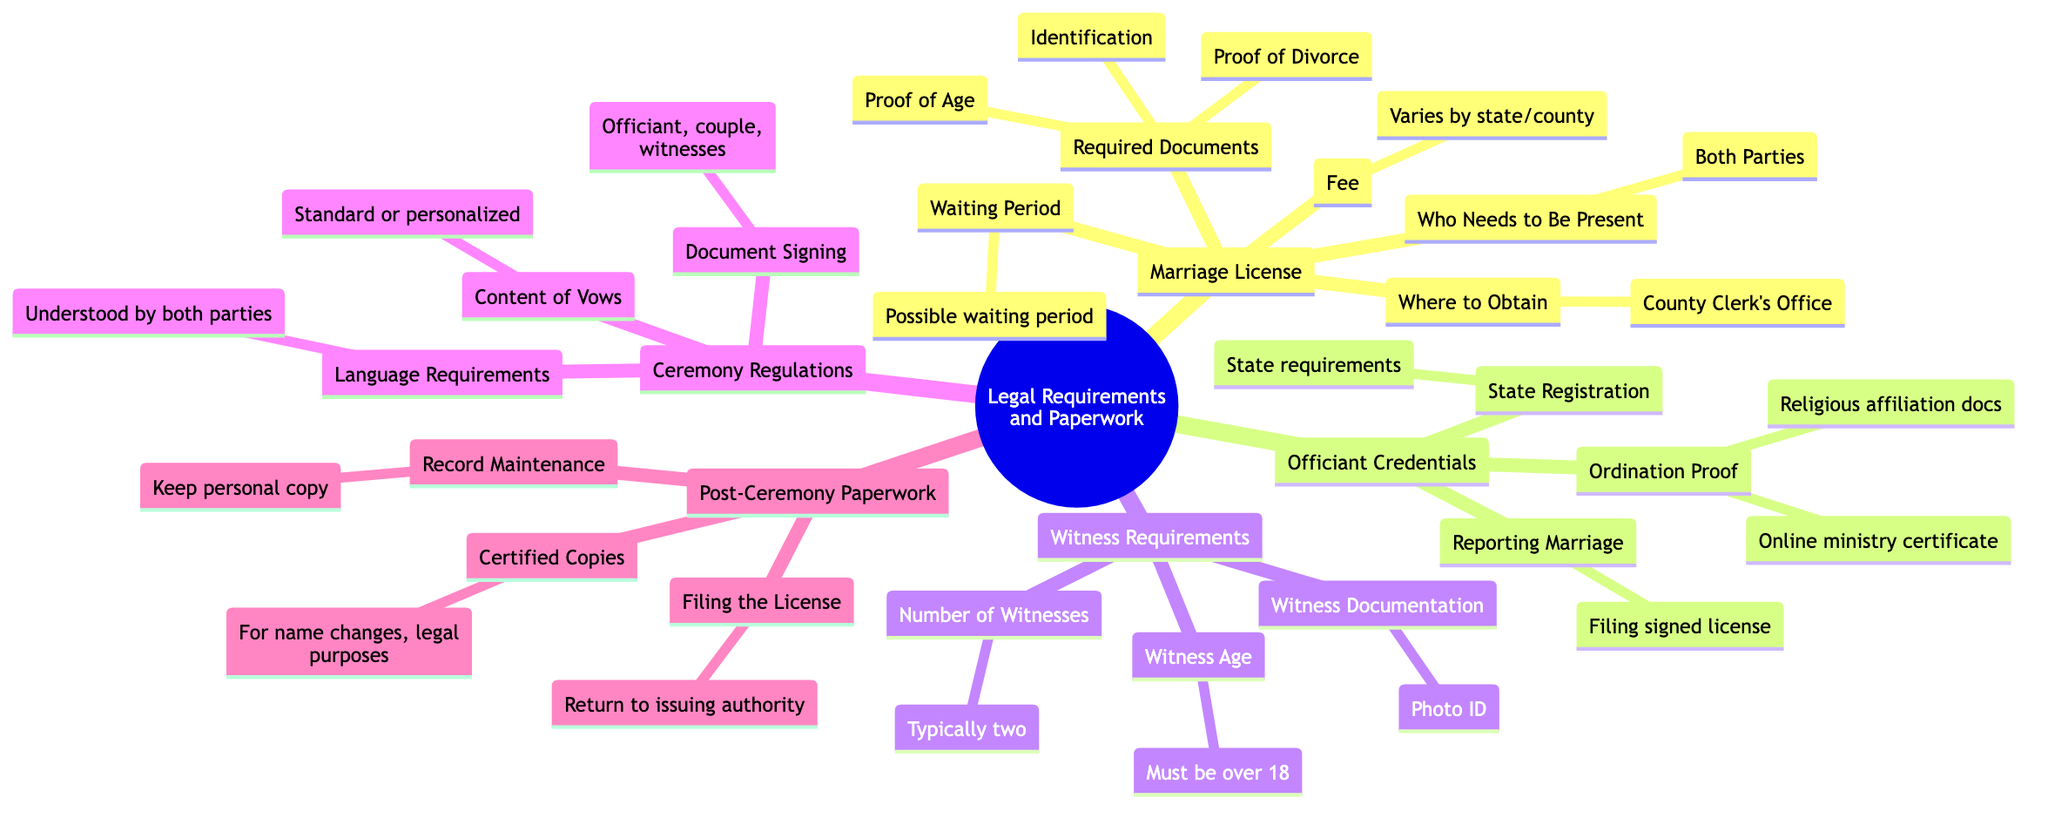What is the county office where you obtain the marriage license? The diagram indicates that the marriage license can be obtained at the County Clerk's Office, as it is explicitly stated under the "Marriage License" section.
Answer: County Clerk's Office How many witnesses are required for the ceremony? According to the "Witness Requirements" section of the diagram, it specifies that typically two witnesses are required.
Answer: Typically two What is one required document for obtaining a marriage license? The diagram lists several required documents under the "Required Documents" node for the marriage license. One example directly mentioned is Identification.
Answer: Identification What must the witnesses' age be? The "Witness Age" information provided in the "Witness Requirements" section states that witnesses must be over 18 years old.
Answer: Must be over 18 What types of vows can be included in the ceremony? The "Content of Vows" section under "Ceremony Regulations" states that vows can either be standard or personalized, providing two distinct types that are accepted.
Answer: Standard or personalized How is the marriage reported after the ceremony? The diagram states under "Reporting Marriage" in the "Officiant Credentials" section that the marriage is reported by filing the signed marriage license with the county, clarifying the necessary action.
Answer: Filing the signed license What is the purpose of obtaining certified copies after the ceremony? Under "Certified Copies" in the "Post-Ceremony Paperwork" section, the diagram mentions that these copies are needed for name changes and legal purposes, explaining their relevance.
Answer: For name changes, legal purposes What is the waiting period before a marriage license is valid? The diagram mentions a "Possible waiting period" in the "Marriage License" section, indicating that there may be a delay before the license can be used.
Answer: Possible waiting period Who needs to be present to obtain the marriage license? The "Who Needs to Be Present" section under the "Marriage License" category specifies that both parties must be present when obtaining the license.
Answer: Both Parties 